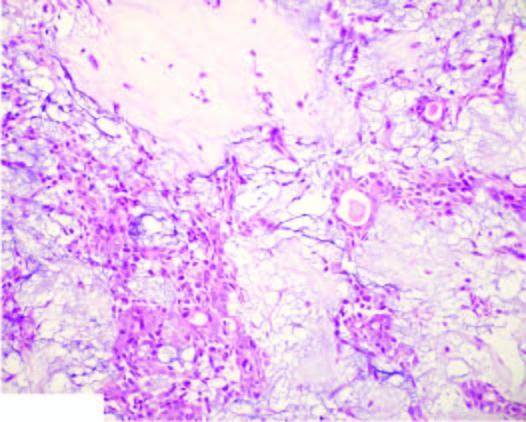what is the epithelial element comprised of?
Answer the question using a single word or phrase. Ducts 